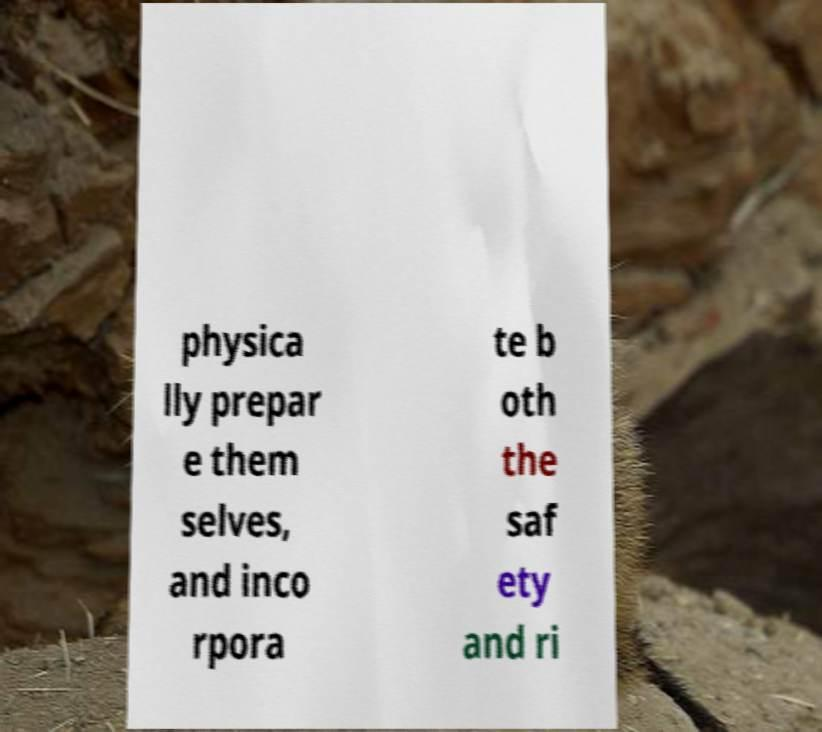Please read and relay the text visible in this image. What does it say? physica lly prepar e them selves, and inco rpora te b oth the saf ety and ri 